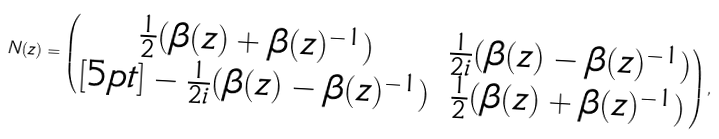<formula> <loc_0><loc_0><loc_500><loc_500>N ( z ) = \begin{pmatrix} \frac { 1 } { 2 } ( \beta ( z ) + \beta ( z ) ^ { - 1 } ) & \frac { 1 } { 2 i } ( \beta ( z ) - \beta ( z ) ^ { - 1 } ) \\ [ 5 p t ] - \frac { 1 } { 2 i } ( \beta ( z ) - \beta ( z ) ^ { - 1 } ) & \frac { 1 } { 2 } ( \beta ( z ) + \beta ( z ) ^ { - 1 } ) \end{pmatrix} ,</formula> 